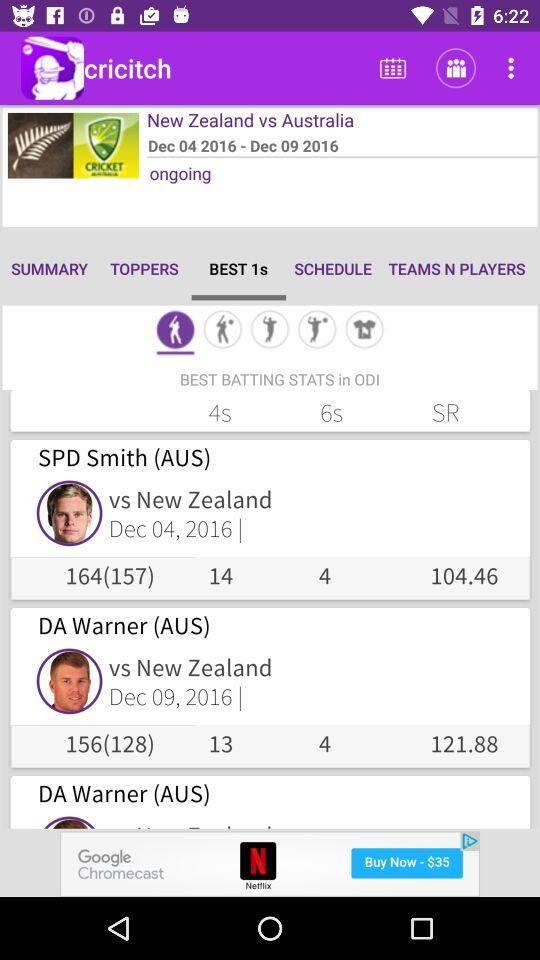Which player has the best batting stats in ODI? The players that have the best batting stats in ODI are SPD Smith and DA Warner. 